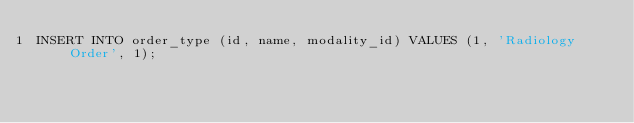Convert code to text. <code><loc_0><loc_0><loc_500><loc_500><_SQL_>INSERT INTO order_type (id, name, modality_id) VALUES (1, 'Radiology Order', 1);</code> 